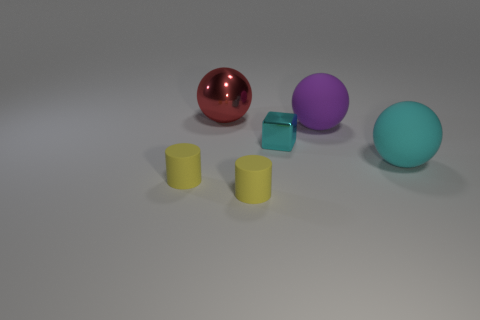Add 3 purple metallic spheres. How many objects exist? 9 Subtract all cubes. How many objects are left? 5 Subtract 0 green blocks. How many objects are left? 6 Subtract all yellow objects. Subtract all shiny spheres. How many objects are left? 3 Add 6 purple objects. How many purple objects are left? 7 Add 1 tiny blue shiny objects. How many tiny blue shiny objects exist? 1 